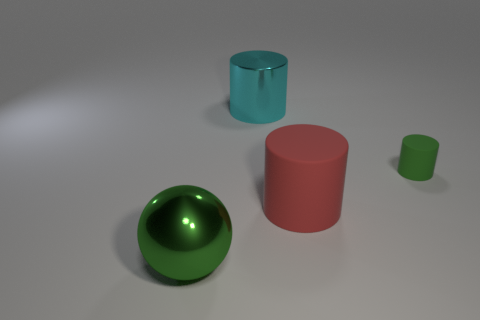Add 2 rubber things. How many objects exist? 6 Subtract all spheres. How many objects are left? 3 Subtract 0 gray cubes. How many objects are left? 4 Subtract all small green matte cylinders. Subtract all red rubber cylinders. How many objects are left? 2 Add 4 red things. How many red things are left? 5 Add 2 big blocks. How many big blocks exist? 2 